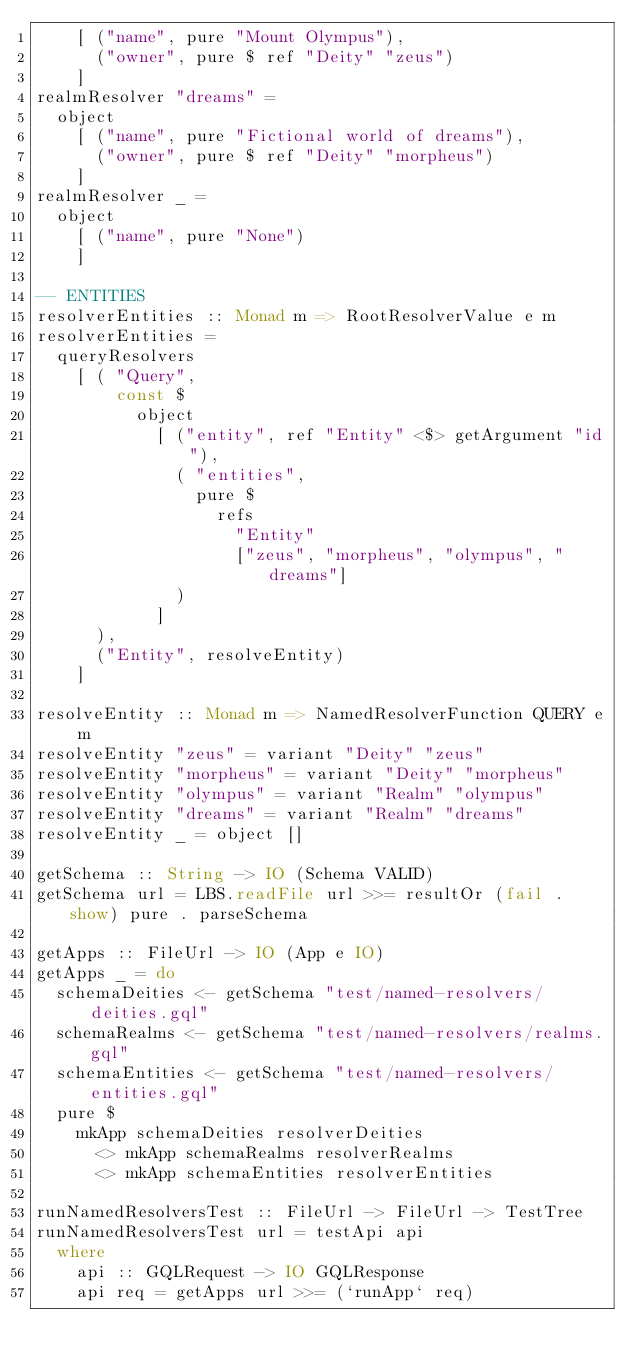<code> <loc_0><loc_0><loc_500><loc_500><_Haskell_>    [ ("name", pure "Mount Olympus"),
      ("owner", pure $ ref "Deity" "zeus")
    ]
realmResolver "dreams" =
  object
    [ ("name", pure "Fictional world of dreams"),
      ("owner", pure $ ref "Deity" "morpheus")
    ]
realmResolver _ =
  object
    [ ("name", pure "None")
    ]

-- ENTITIES
resolverEntities :: Monad m => RootResolverValue e m
resolverEntities =
  queryResolvers
    [ ( "Query",
        const $
          object
            [ ("entity", ref "Entity" <$> getArgument "id"),
              ( "entities",
                pure $
                  refs
                    "Entity"
                    ["zeus", "morpheus", "olympus", "dreams"]
              )
            ]
      ),
      ("Entity", resolveEntity)
    ]

resolveEntity :: Monad m => NamedResolverFunction QUERY e m
resolveEntity "zeus" = variant "Deity" "zeus"
resolveEntity "morpheus" = variant "Deity" "morpheus"
resolveEntity "olympus" = variant "Realm" "olympus"
resolveEntity "dreams" = variant "Realm" "dreams"
resolveEntity _ = object []

getSchema :: String -> IO (Schema VALID)
getSchema url = LBS.readFile url >>= resultOr (fail . show) pure . parseSchema

getApps :: FileUrl -> IO (App e IO)
getApps _ = do
  schemaDeities <- getSchema "test/named-resolvers/deities.gql"
  schemaRealms <- getSchema "test/named-resolvers/realms.gql"
  schemaEntities <- getSchema "test/named-resolvers/entities.gql"
  pure $
    mkApp schemaDeities resolverDeities
      <> mkApp schemaRealms resolverRealms
      <> mkApp schemaEntities resolverEntities

runNamedResolversTest :: FileUrl -> FileUrl -> TestTree
runNamedResolversTest url = testApi api
  where
    api :: GQLRequest -> IO GQLResponse
    api req = getApps url >>= (`runApp` req)
</code> 